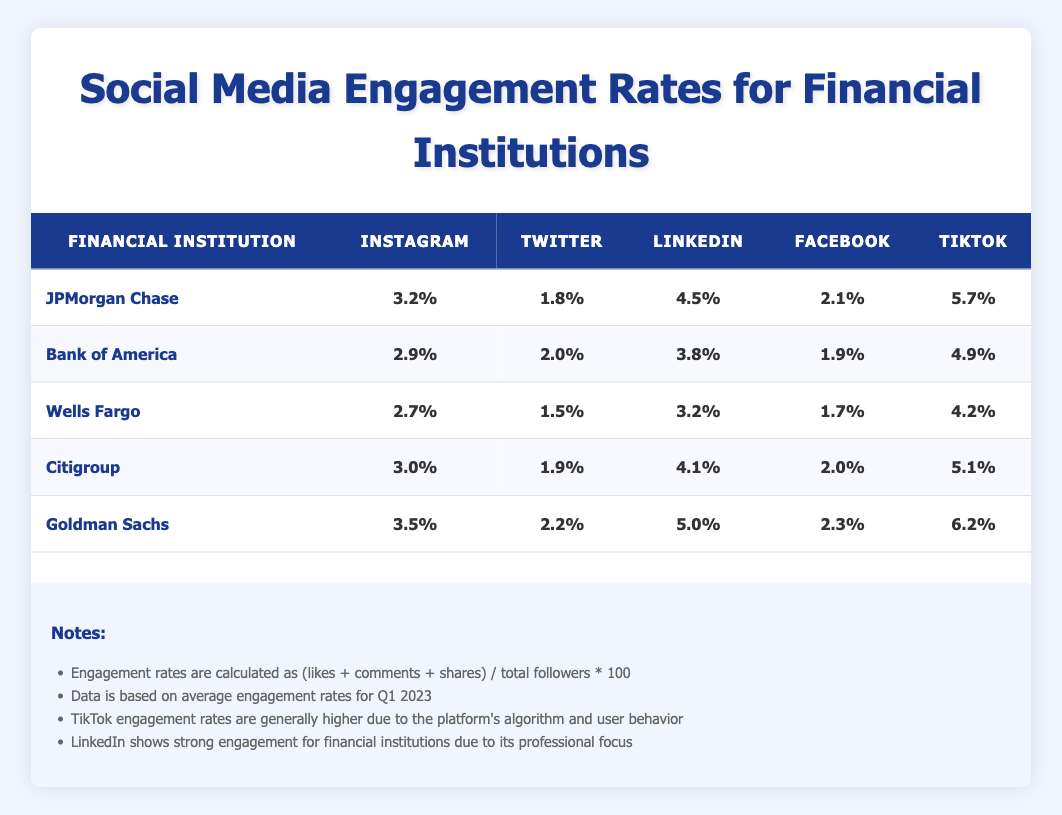What is the highest engagement rate on Instagram among the financial institutions? By examining the engagement rates for Instagram in the table, the highest rate is held by Goldman Sachs with a rate of 3.5%.
Answer: 3.5% Which financial institution has the lowest engagement rate on Twitter? The table shows that Wells Fargo has the lowest engagement rate on Twitter at 1.5%.
Answer: 1.5% What is the average engagement rate on LinkedIn for all listed financial institutions? The engagement rates on LinkedIn for each institution are 4.5%, 3.8%, 3.2%, 4.1%, and 5.0%. Their sum is 20.6% and there are 5 institutions, so the average is 20.6% / 5 = 4.12%.
Answer: 4.12% Is the TikTok engagement rate of JPMorgan Chase higher than Citigroup? JPMorgan Chase has a TikTok engagement rate of 5.7%, while Citigroup has a rate of 5.1%. Since 5.7% is greater than 5.1%, the answer is yes.
Answer: Yes What is the difference between the highest and lowest engagement rates on Facebook among the financial institutions? Looking at the Facebook engagement rates, Goldman Sachs has the highest at 2.3% and Wells Fargo has the lowest at 1.7%. The difference is 2.3% - 1.7% = 0.6%.
Answer: 0.6% 